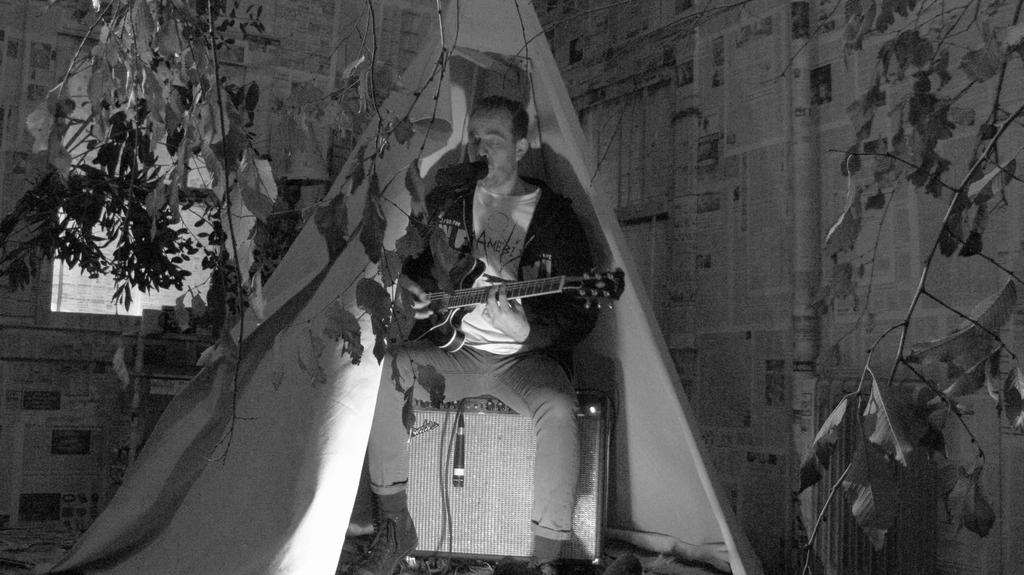What is the man in the image doing? The man is seated and playing a guitar. What object is in front of the man? There is a microphone in front of the man. What can be seen in the background of the image? There is a tree and a building visible in the image. How many strangers are present in the image? There is no stranger present in the image; it only features a man playing a guitar. What type of throne is the man sitting on in the image? There is no throne present in the image; the man is seated on a regular chair or bench. 